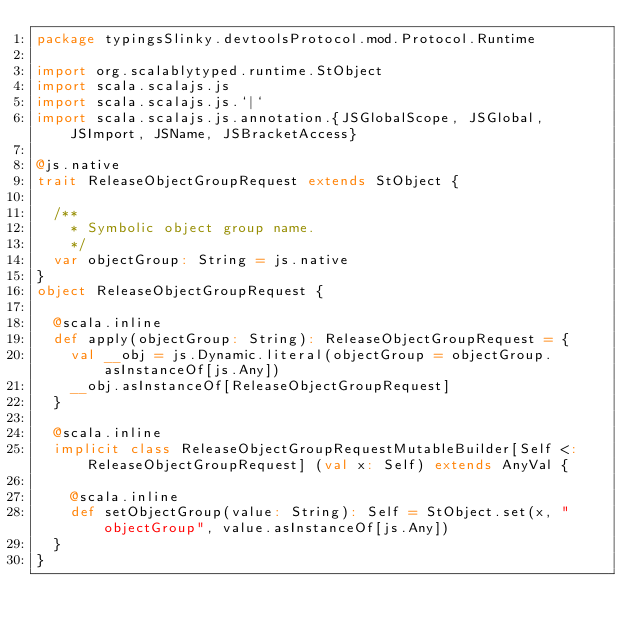<code> <loc_0><loc_0><loc_500><loc_500><_Scala_>package typingsSlinky.devtoolsProtocol.mod.Protocol.Runtime

import org.scalablytyped.runtime.StObject
import scala.scalajs.js
import scala.scalajs.js.`|`
import scala.scalajs.js.annotation.{JSGlobalScope, JSGlobal, JSImport, JSName, JSBracketAccess}

@js.native
trait ReleaseObjectGroupRequest extends StObject {
  
  /**
    * Symbolic object group name.
    */
  var objectGroup: String = js.native
}
object ReleaseObjectGroupRequest {
  
  @scala.inline
  def apply(objectGroup: String): ReleaseObjectGroupRequest = {
    val __obj = js.Dynamic.literal(objectGroup = objectGroup.asInstanceOf[js.Any])
    __obj.asInstanceOf[ReleaseObjectGroupRequest]
  }
  
  @scala.inline
  implicit class ReleaseObjectGroupRequestMutableBuilder[Self <: ReleaseObjectGroupRequest] (val x: Self) extends AnyVal {
    
    @scala.inline
    def setObjectGroup(value: String): Self = StObject.set(x, "objectGroup", value.asInstanceOf[js.Any])
  }
}
</code> 